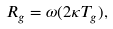Convert formula to latex. <formula><loc_0><loc_0><loc_500><loc_500>R _ { g } = \omega ( 2 \kappa T _ { g } ) ,</formula> 